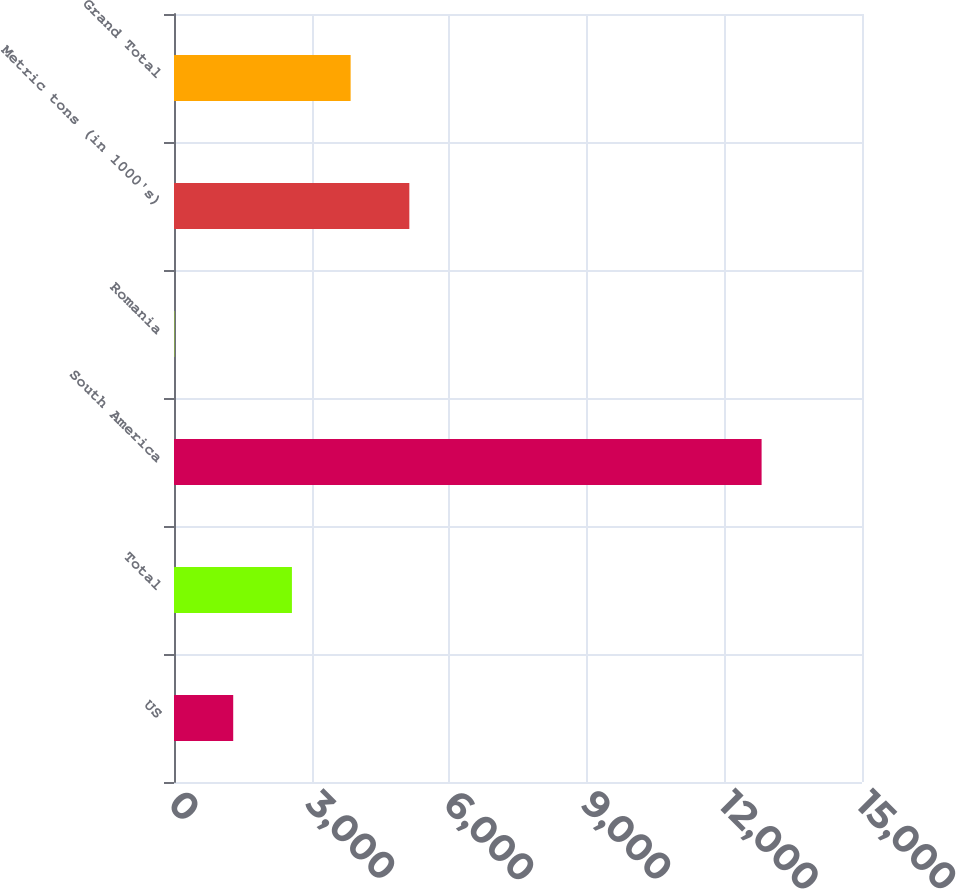Convert chart to OTSL. <chart><loc_0><loc_0><loc_500><loc_500><bar_chart><fcel>US<fcel>Total<fcel>South America<fcel>Romania<fcel>Metric tons (in 1000's)<fcel>Grand Total<nl><fcel>1291<fcel>2571<fcel>12811<fcel>11<fcel>5131<fcel>3851<nl></chart> 